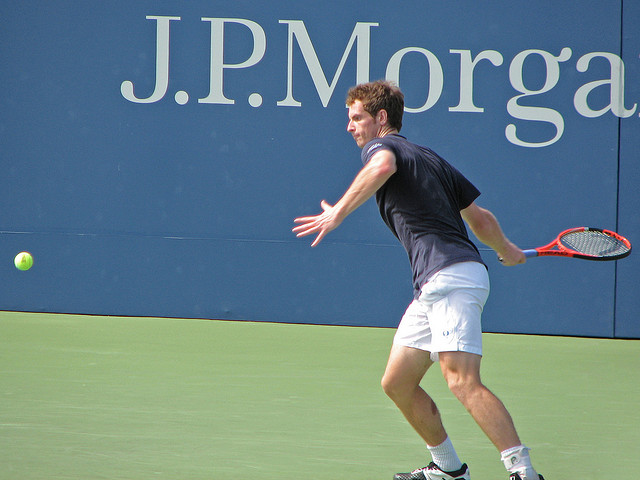Identify the text displayed in this image. J.P.Morga 